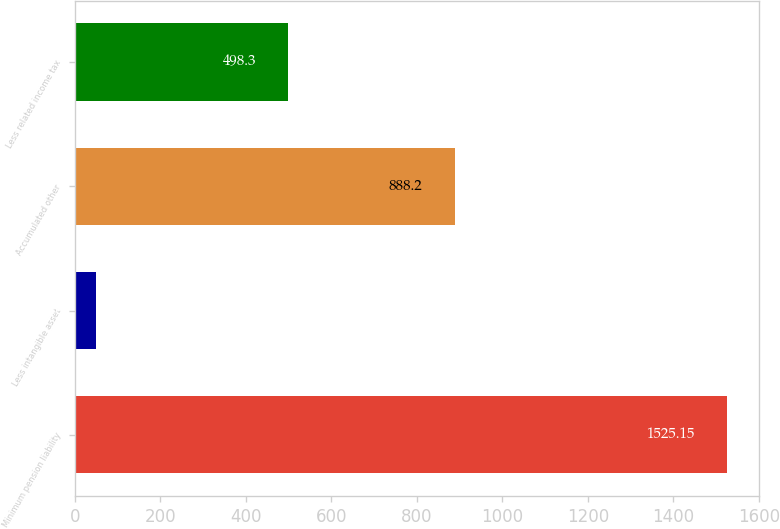Convert chart. <chart><loc_0><loc_0><loc_500><loc_500><bar_chart><fcel>Minimum pension liability<fcel>Less intangible asset<fcel>Accumulated other<fcel>Less related income tax<nl><fcel>1525.15<fcel>50<fcel>888.2<fcel>498.3<nl></chart> 